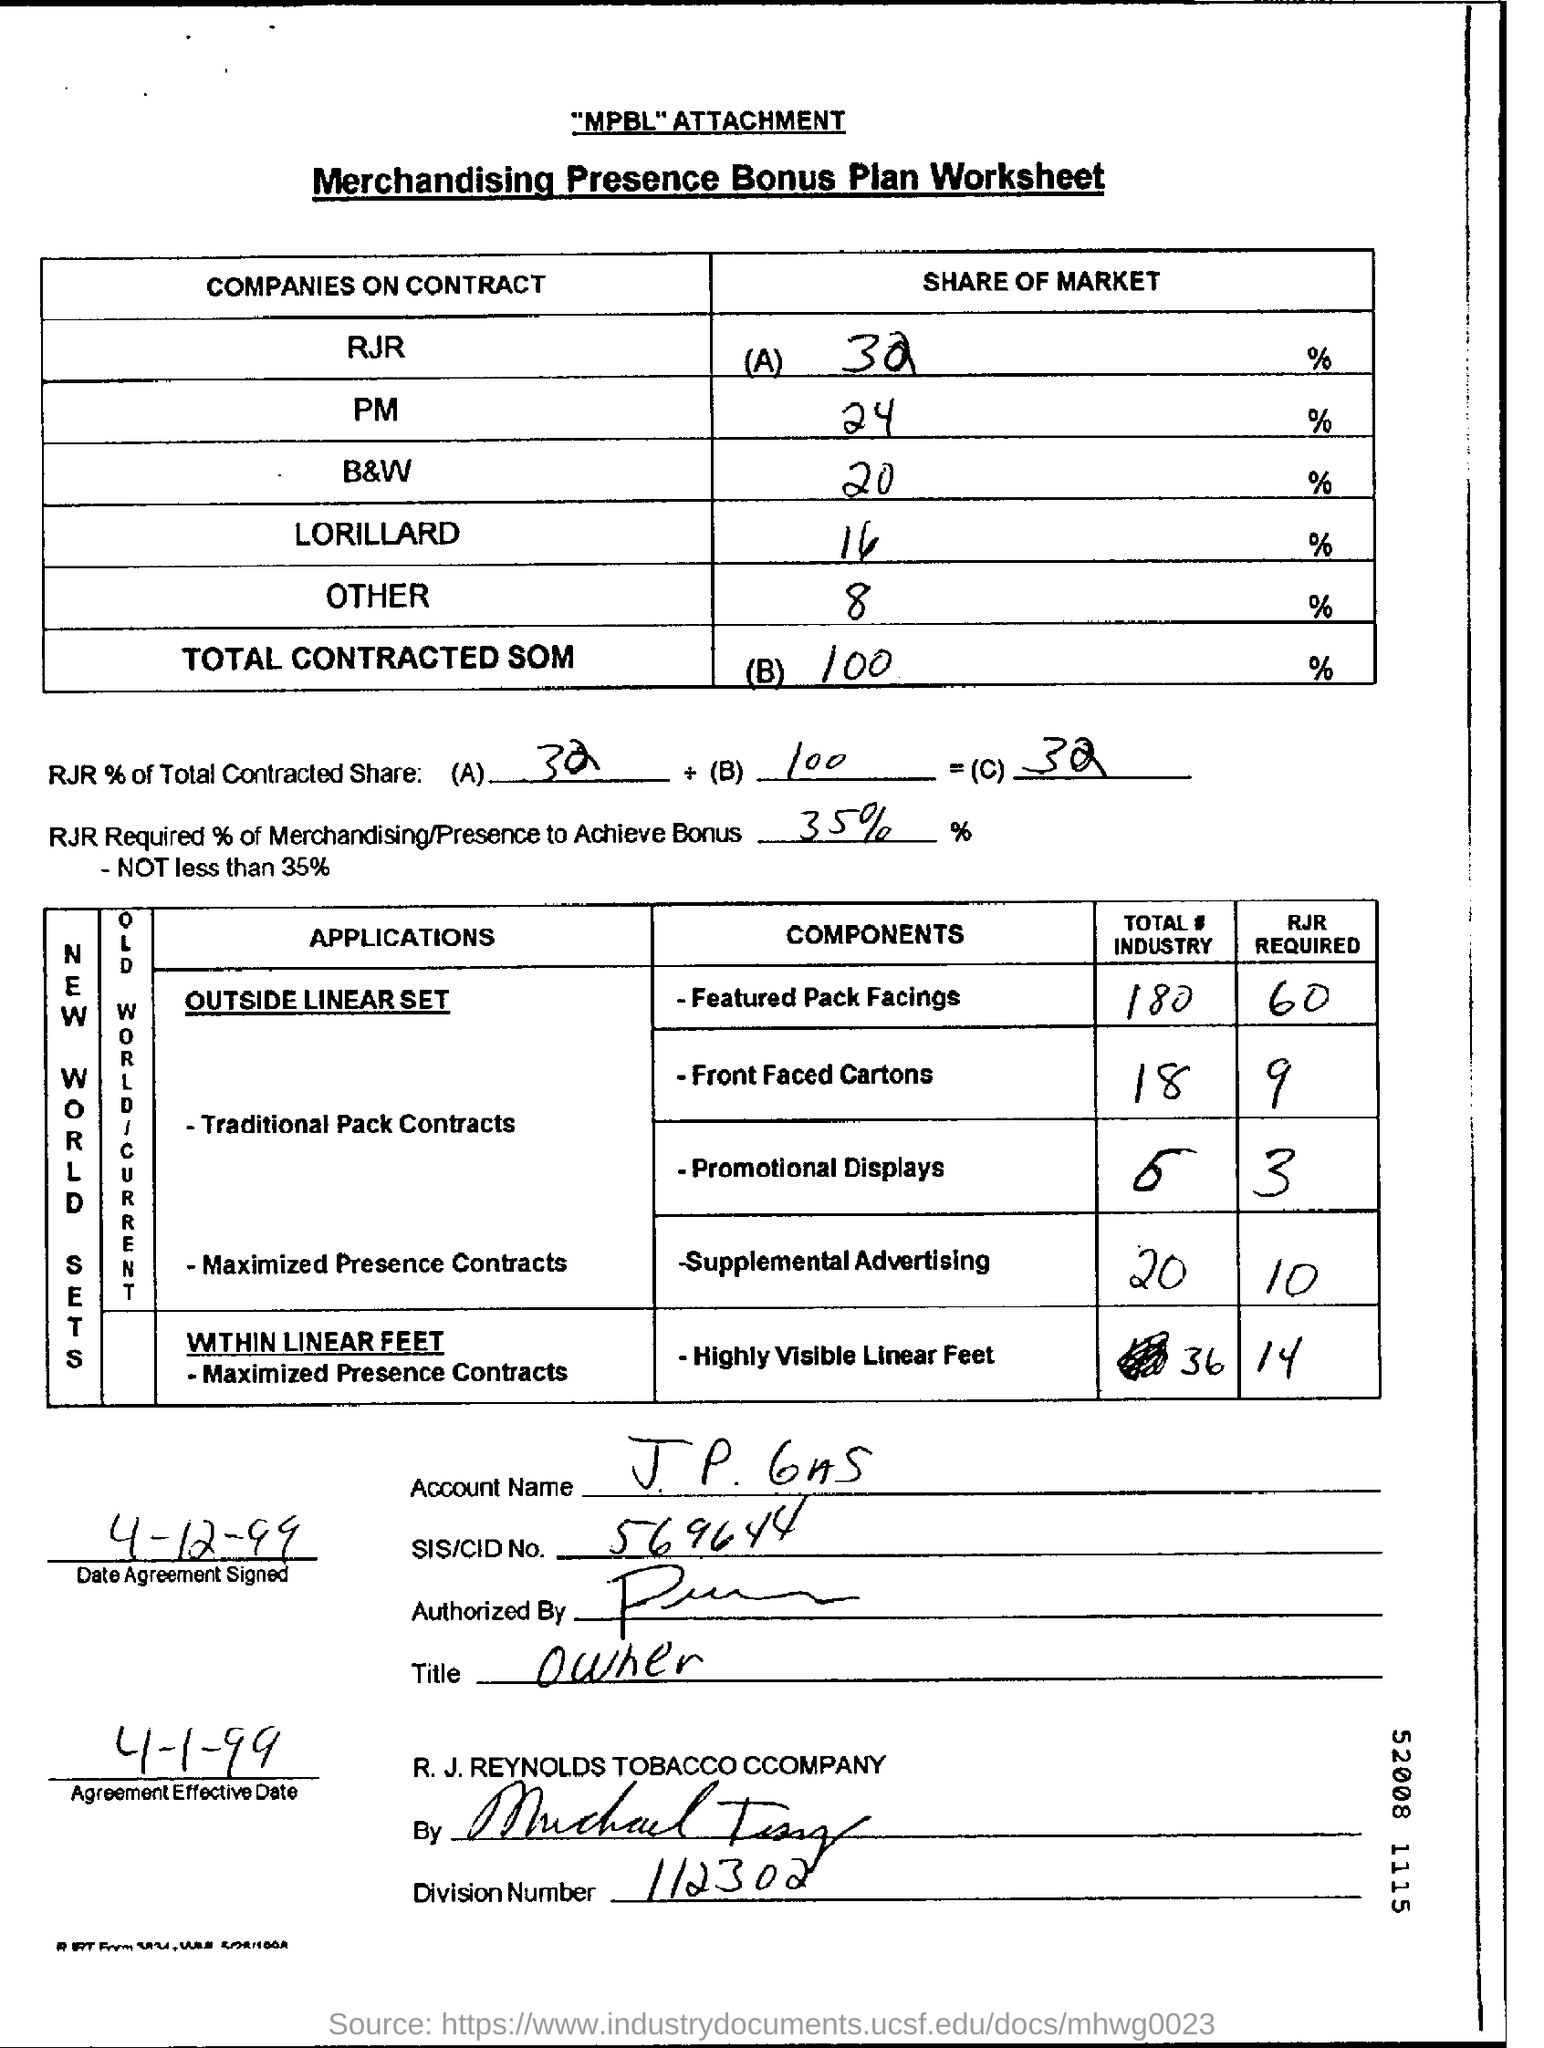What is the SIS/CID Number ?
Your answer should be very brief. 569644. What is written in the Title Field ?
Keep it short and to the point. Owner. What is the Division Number ?
Provide a succinct answer. 112302. 